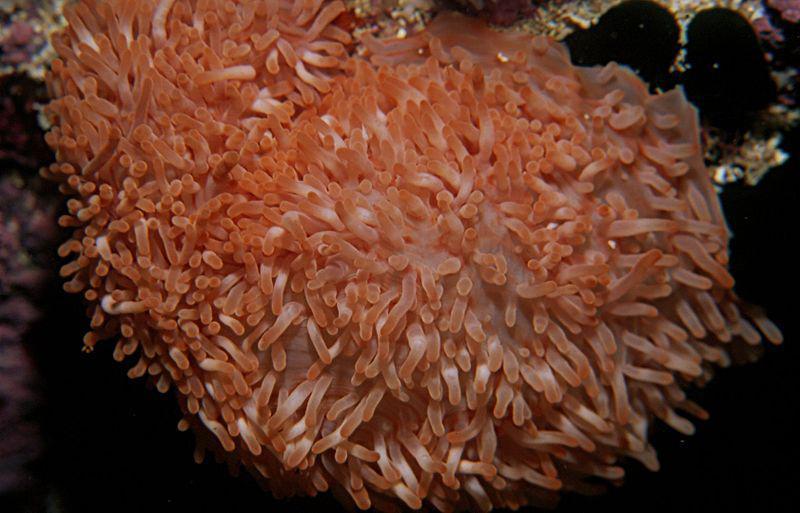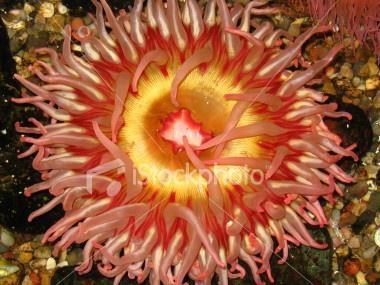The first image is the image on the left, the second image is the image on the right. Considering the images on both sides, is "Both images contain anemone colored a peachy coral hue." valid? Answer yes or no. Yes. 